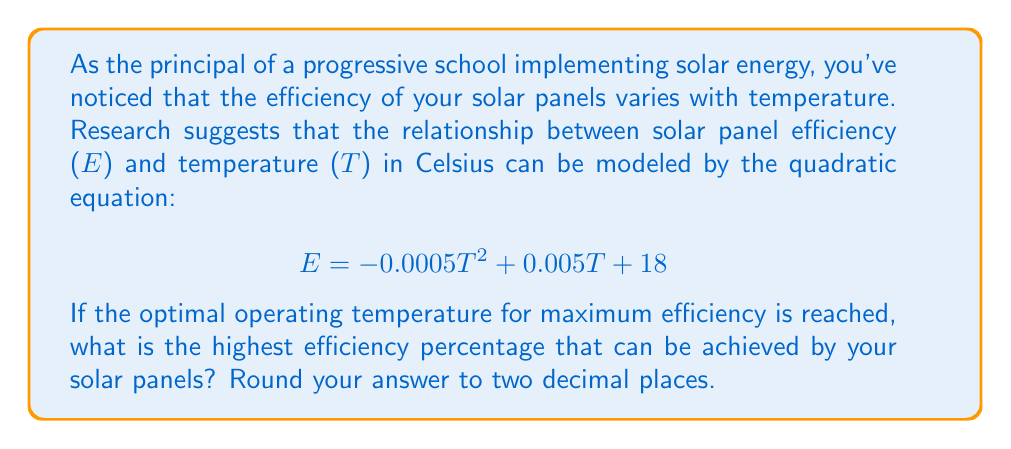Can you answer this question? To find the maximum efficiency, we need to determine the vertex of the parabola represented by the given quadratic equation. The vertex represents the highest point of the parabola, which in this case corresponds to the maximum efficiency.

For a quadratic equation in the form $ax^2 + bx + c$, the x-coordinate of the vertex is given by $x = -\frac{b}{2a}$.

In our equation $E = -0.0005T^2 + 0.005T + 18$:
$a = -0.0005$
$b = 0.005$
$c = 18$

1) Calculate the optimal temperature (T):

   $T = -\frac{b}{2a} = -\frac{0.005}{2(-0.0005)} = 5°C$

2) To find the maximum efficiency, substitute this T value into the original equation:

   $E = -0.0005(5)^2 + 0.005(5) + 18$
   $E = -0.0005(25) + 0.025 + 18$
   $E = -0.0125 + 0.025 + 18$
   $E = 18.0125$

3) Convert to a percentage by multiplying by 100:

   $18.0125 * 100 = 1801.25\%$

4) Round to two decimal places:

   $1801.25\% ≈ 18.01\%$

Therefore, the highest efficiency percentage that can be achieved is 18.01%.
Answer: 18.01% 